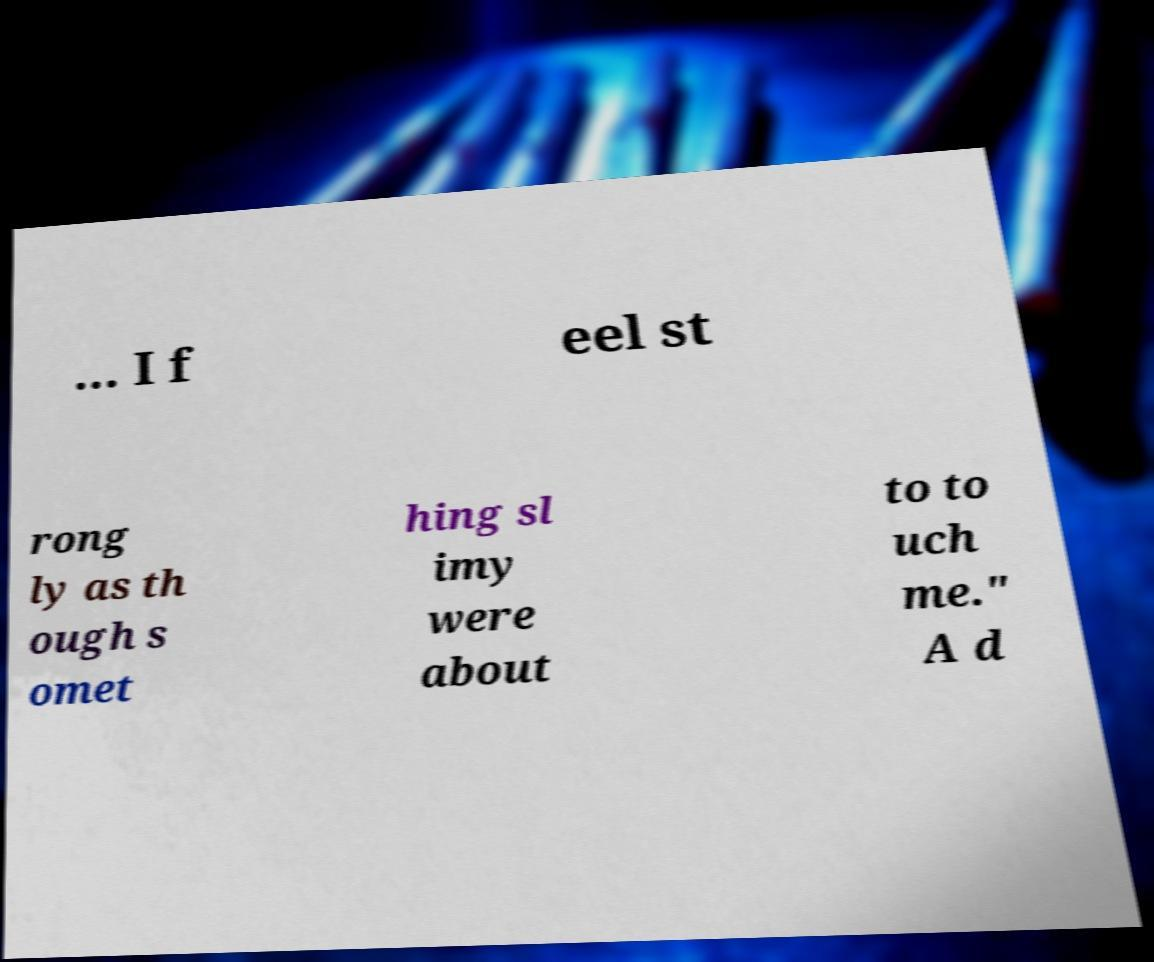Can you accurately transcribe the text from the provided image for me? ... I f eel st rong ly as th ough s omet hing sl imy were about to to uch me." A d 